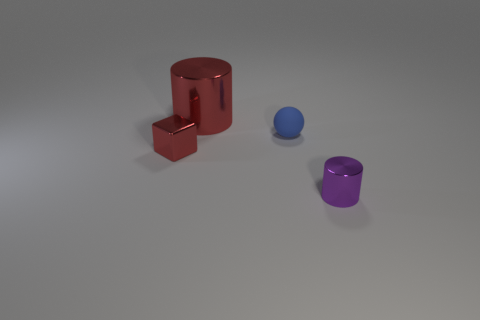Add 2 green matte balls. How many objects exist? 6 Subtract all balls. How many objects are left? 3 Subtract all big purple matte spheres. Subtract all red metallic things. How many objects are left? 2 Add 2 small cylinders. How many small cylinders are left? 3 Add 4 big red matte cylinders. How many big red matte cylinders exist? 4 Subtract 0 brown spheres. How many objects are left? 4 